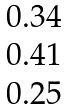<formula> <loc_0><loc_0><loc_500><loc_500>\begin{matrix} 0 . 3 4 \\ 0 . 4 1 \\ 0 . 2 5 \\ \end{matrix}</formula> 